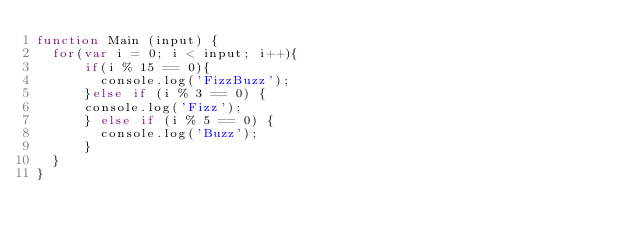Convert code to text. <code><loc_0><loc_0><loc_500><loc_500><_JavaScript_>function Main (input) {
  for(var i = 0; i < input; i++){
      if(i % 15 == 0){
        console.log('FizzBuzz');
      }else if (i % 3 == 0) {
      console.log('Fizz');
      } else if (i % 5 == 0) {
        console.log('Buzz');
      }
  }
}</code> 